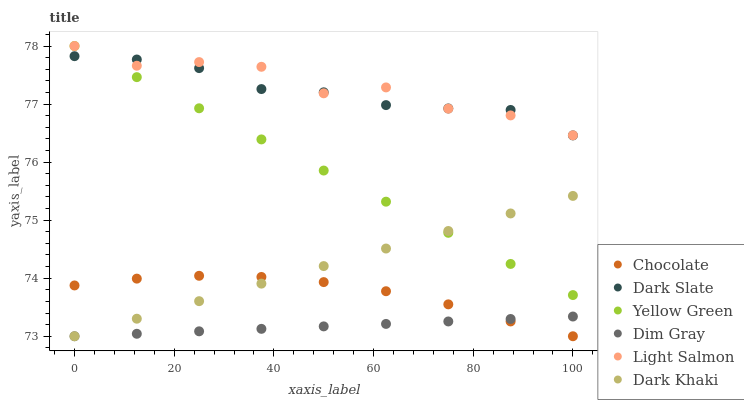Does Dim Gray have the minimum area under the curve?
Answer yes or no. Yes. Does Light Salmon have the maximum area under the curve?
Answer yes or no. Yes. Does Yellow Green have the minimum area under the curve?
Answer yes or no. No. Does Yellow Green have the maximum area under the curve?
Answer yes or no. No. Is Yellow Green the smoothest?
Answer yes or no. Yes. Is Light Salmon the roughest?
Answer yes or no. Yes. Is Dim Gray the smoothest?
Answer yes or no. No. Is Dim Gray the roughest?
Answer yes or no. No. Does Dim Gray have the lowest value?
Answer yes or no. Yes. Does Yellow Green have the lowest value?
Answer yes or no. No. Does Yellow Green have the highest value?
Answer yes or no. Yes. Does Dim Gray have the highest value?
Answer yes or no. No. Is Dim Gray less than Dark Slate?
Answer yes or no. Yes. Is Dark Slate greater than Chocolate?
Answer yes or no. Yes. Does Dim Gray intersect Chocolate?
Answer yes or no. Yes. Is Dim Gray less than Chocolate?
Answer yes or no. No. Is Dim Gray greater than Chocolate?
Answer yes or no. No. Does Dim Gray intersect Dark Slate?
Answer yes or no. No. 